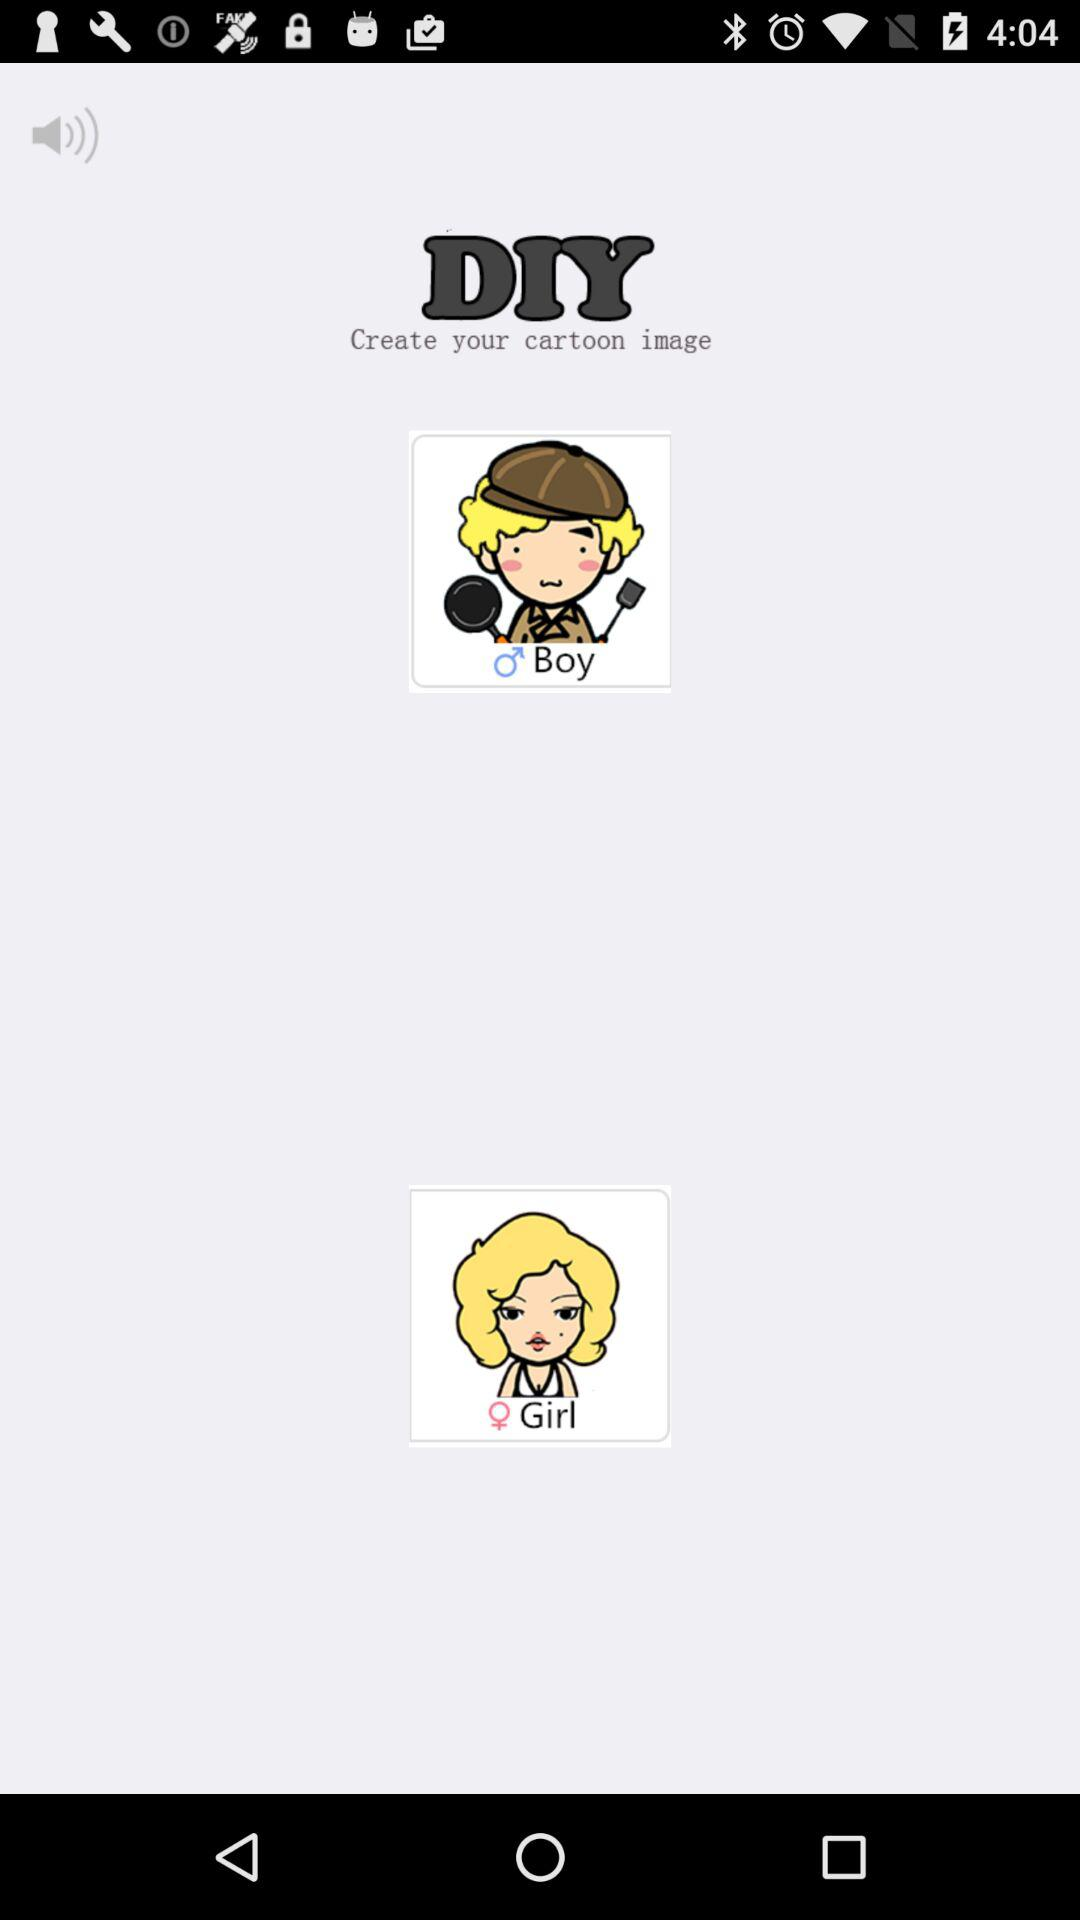What are the gender options available? The available gender options are boy and girl. 